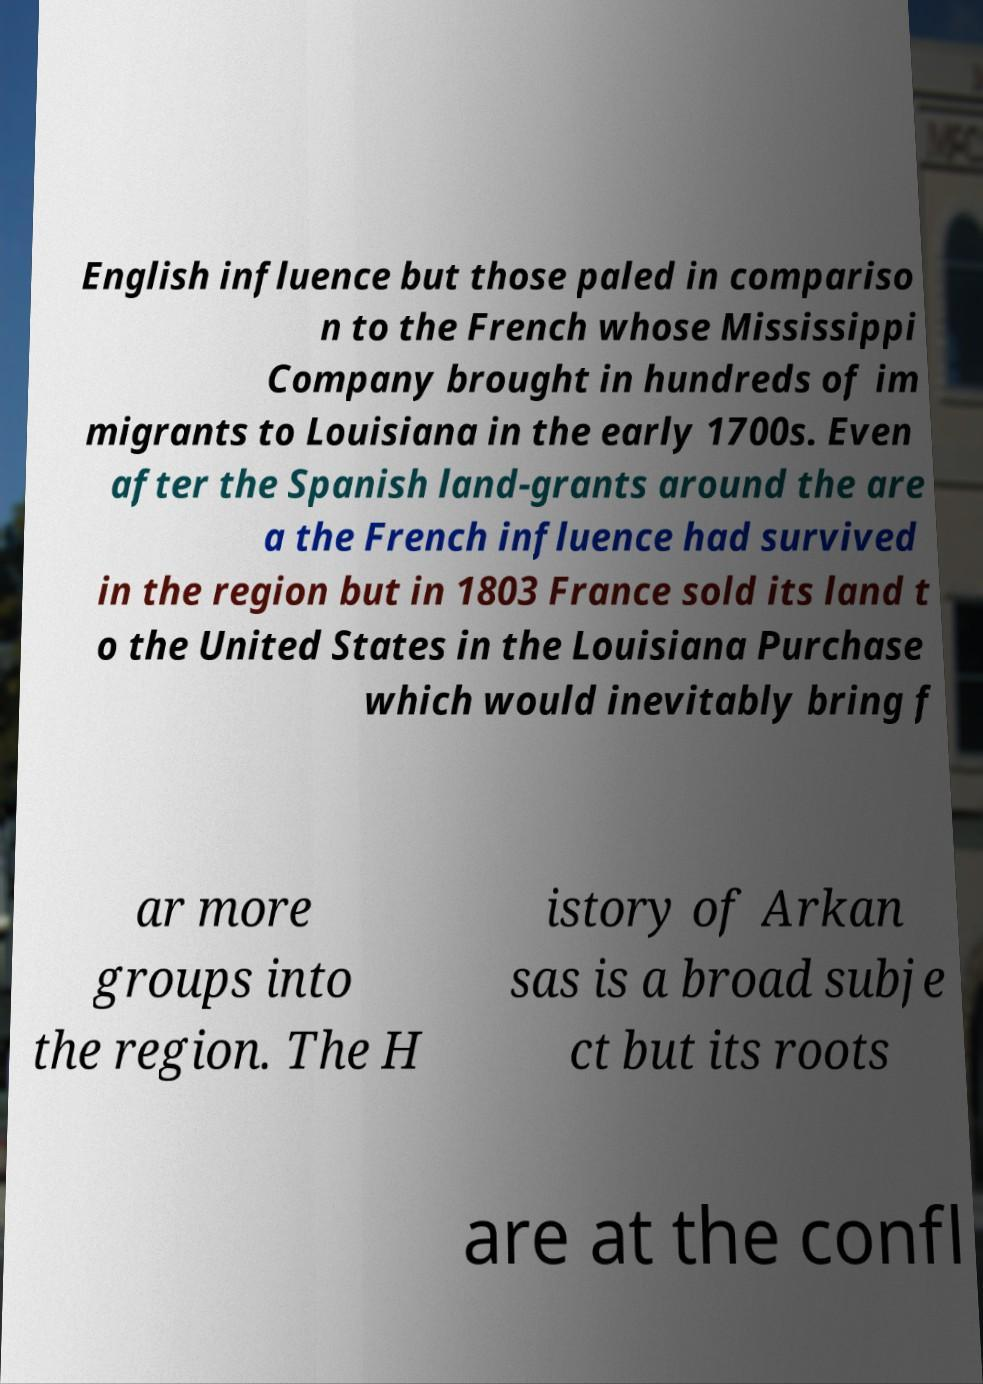Can you accurately transcribe the text from the provided image for me? English influence but those paled in compariso n to the French whose Mississippi Company brought in hundreds of im migrants to Louisiana in the early 1700s. Even after the Spanish land-grants around the are a the French influence had survived in the region but in 1803 France sold its land t o the United States in the Louisiana Purchase which would inevitably bring f ar more groups into the region. The H istory of Arkan sas is a broad subje ct but its roots are at the confl 